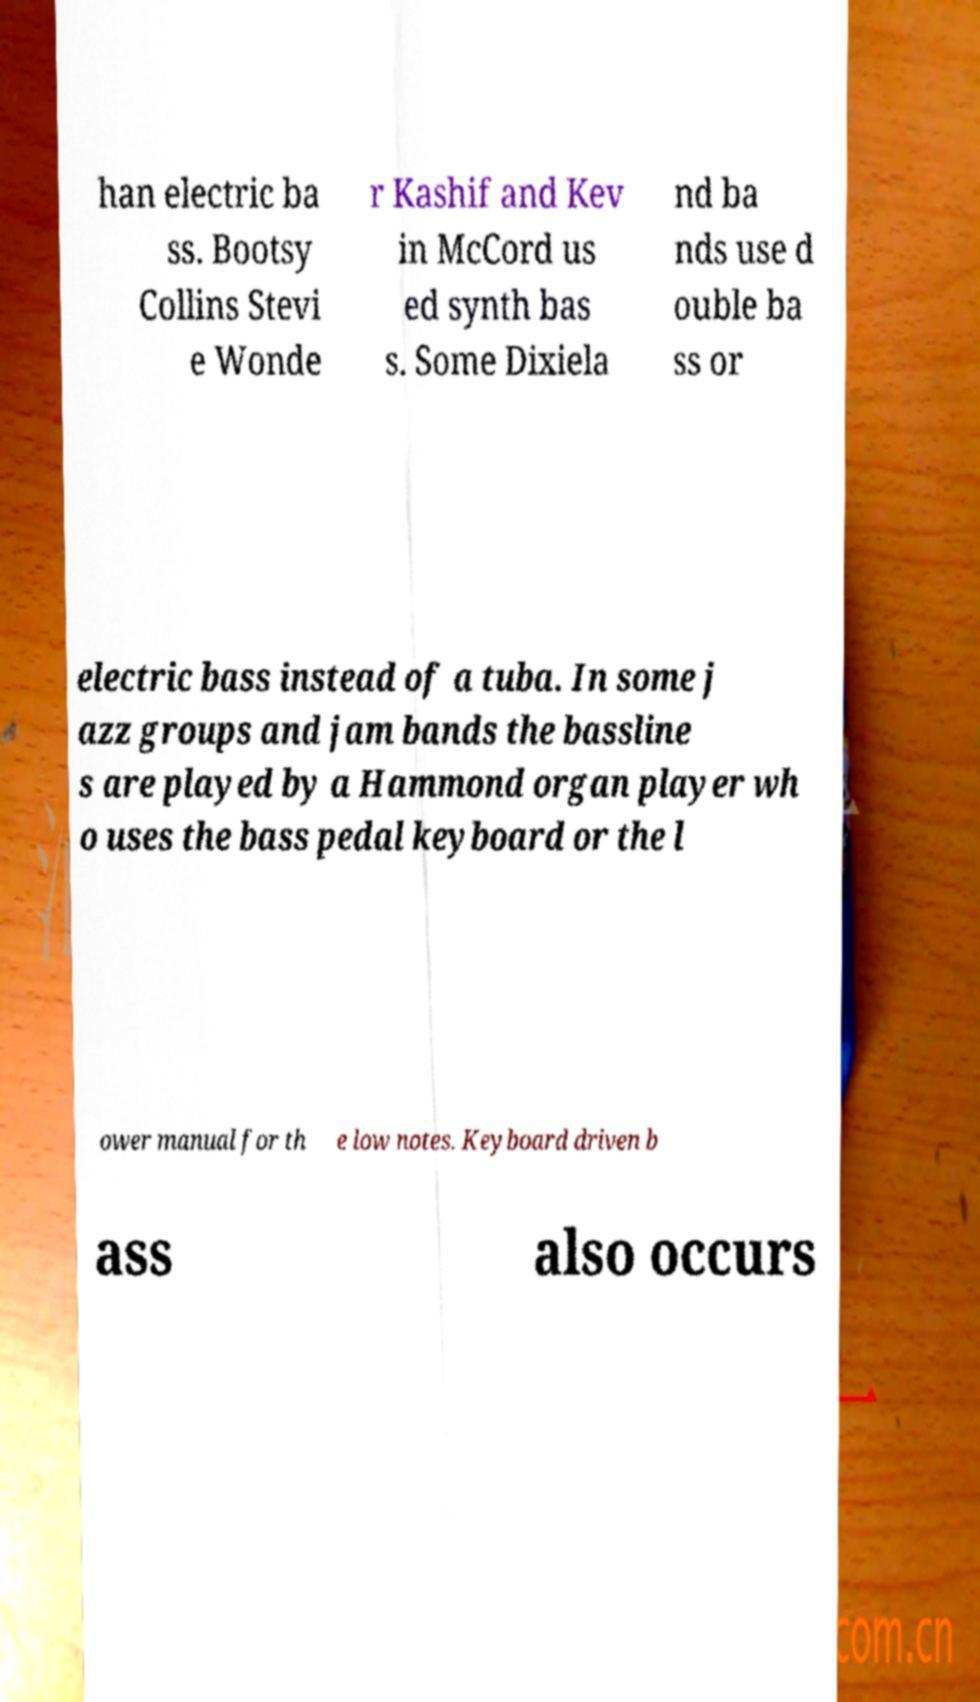I need the written content from this picture converted into text. Can you do that? han electric ba ss. Bootsy Collins Stevi e Wonde r Kashif and Kev in McCord us ed synth bas s. Some Dixiela nd ba nds use d ouble ba ss or electric bass instead of a tuba. In some j azz groups and jam bands the bassline s are played by a Hammond organ player wh o uses the bass pedal keyboard or the l ower manual for th e low notes. Keyboard driven b ass also occurs 